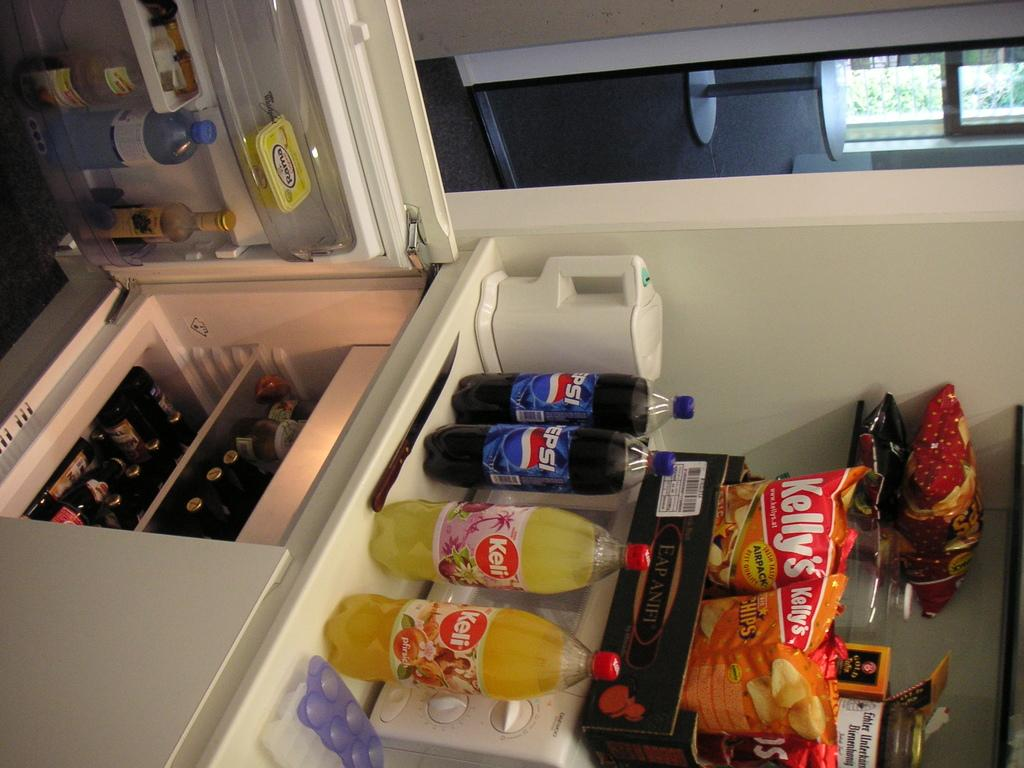Provide a one-sentence caption for the provided image. The contents of a shelf are shown that contain Pepsi drinks, Keli drinks, and Kelly's brand potato chips. 